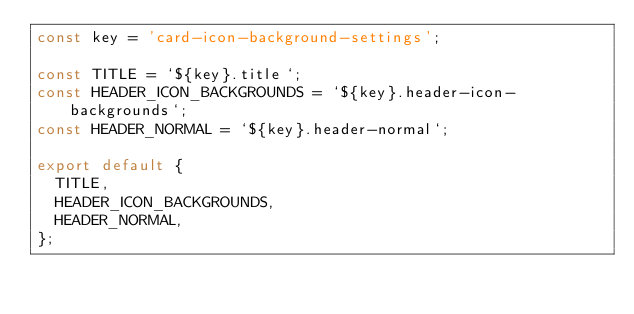Convert code to text. <code><loc_0><loc_0><loc_500><loc_500><_JavaScript_>const key = 'card-icon-background-settings';

const TITLE = `${key}.title`;
const HEADER_ICON_BACKGROUNDS = `${key}.header-icon-backgrounds`;
const HEADER_NORMAL = `${key}.header-normal`;

export default {
  TITLE,
  HEADER_ICON_BACKGROUNDS,
  HEADER_NORMAL,
};
</code> 